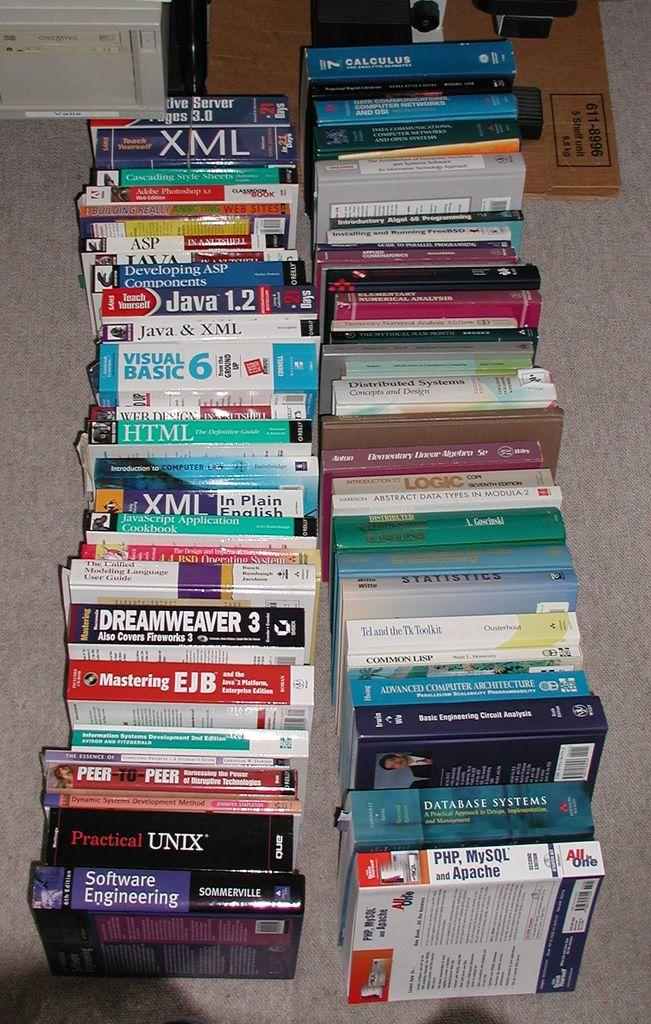<image>
Offer a succinct explanation of the picture presented. rows of books with one of them titled 'software engineering' 